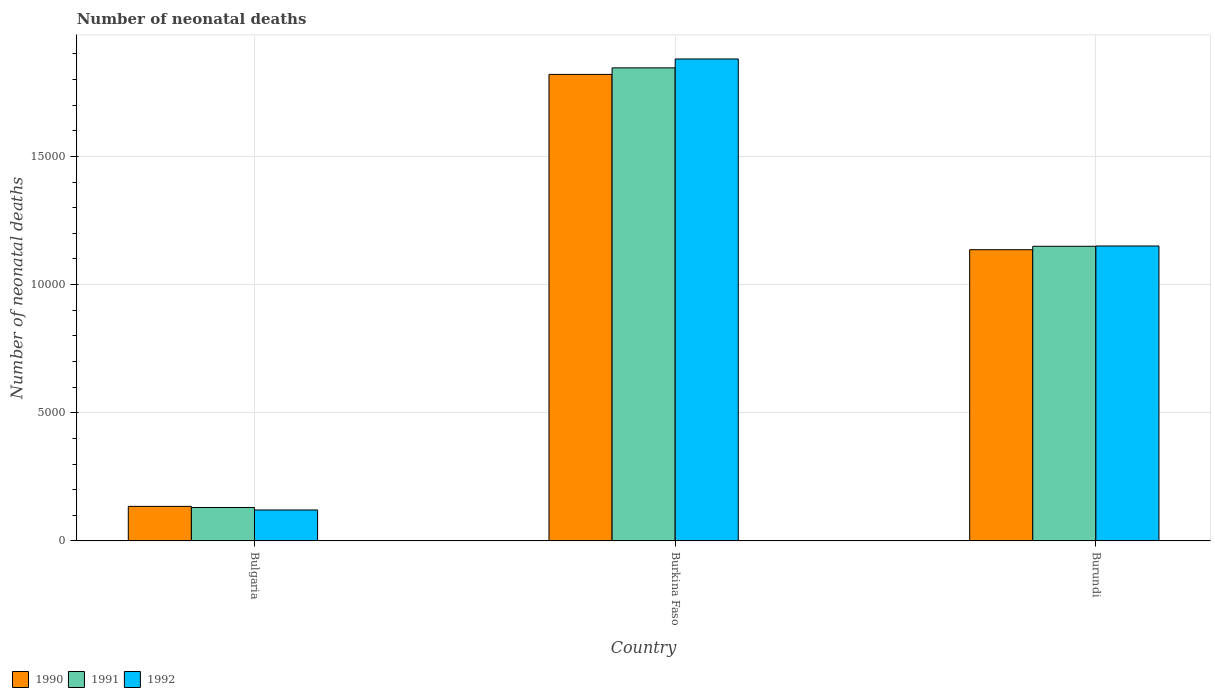How many different coloured bars are there?
Ensure brevity in your answer.  3. How many groups of bars are there?
Provide a succinct answer. 3. What is the number of neonatal deaths in in 1992 in Bulgaria?
Your answer should be very brief. 1208. Across all countries, what is the maximum number of neonatal deaths in in 1991?
Your response must be concise. 1.85e+04. Across all countries, what is the minimum number of neonatal deaths in in 1992?
Your answer should be compact. 1208. In which country was the number of neonatal deaths in in 1991 maximum?
Your response must be concise. Burkina Faso. What is the total number of neonatal deaths in in 1990 in the graph?
Make the answer very short. 3.09e+04. What is the difference between the number of neonatal deaths in in 1991 in Bulgaria and that in Burkina Faso?
Provide a short and direct response. -1.72e+04. What is the difference between the number of neonatal deaths in in 1991 in Burkina Faso and the number of neonatal deaths in in 1990 in Bulgaria?
Provide a short and direct response. 1.71e+04. What is the average number of neonatal deaths in in 1991 per country?
Your answer should be compact. 1.04e+04. What is the difference between the number of neonatal deaths in of/in 1991 and number of neonatal deaths in of/in 1992 in Burundi?
Keep it short and to the point. -11. What is the ratio of the number of neonatal deaths in in 1990 in Burkina Faso to that in Burundi?
Keep it short and to the point. 1.6. What is the difference between the highest and the second highest number of neonatal deaths in in 1990?
Your response must be concise. 6839. What is the difference between the highest and the lowest number of neonatal deaths in in 1990?
Offer a terse response. 1.69e+04. In how many countries, is the number of neonatal deaths in in 1990 greater than the average number of neonatal deaths in in 1990 taken over all countries?
Offer a terse response. 2. Is the sum of the number of neonatal deaths in in 1991 in Bulgaria and Burundi greater than the maximum number of neonatal deaths in in 1990 across all countries?
Offer a very short reply. No. What does the 1st bar from the right in Burkina Faso represents?
Make the answer very short. 1992. Are all the bars in the graph horizontal?
Keep it short and to the point. No. What is the difference between two consecutive major ticks on the Y-axis?
Your answer should be compact. 5000. Does the graph contain any zero values?
Provide a short and direct response. No. Does the graph contain grids?
Your answer should be compact. Yes. What is the title of the graph?
Keep it short and to the point. Number of neonatal deaths. What is the label or title of the X-axis?
Your response must be concise. Country. What is the label or title of the Y-axis?
Offer a very short reply. Number of neonatal deaths. What is the Number of neonatal deaths in 1990 in Bulgaria?
Provide a succinct answer. 1348. What is the Number of neonatal deaths in 1991 in Bulgaria?
Your response must be concise. 1305. What is the Number of neonatal deaths in 1992 in Bulgaria?
Your response must be concise. 1208. What is the Number of neonatal deaths in 1990 in Burkina Faso?
Offer a very short reply. 1.82e+04. What is the Number of neonatal deaths of 1991 in Burkina Faso?
Your response must be concise. 1.85e+04. What is the Number of neonatal deaths of 1992 in Burkina Faso?
Your answer should be very brief. 1.88e+04. What is the Number of neonatal deaths in 1990 in Burundi?
Ensure brevity in your answer.  1.14e+04. What is the Number of neonatal deaths in 1991 in Burundi?
Keep it short and to the point. 1.15e+04. What is the Number of neonatal deaths of 1992 in Burundi?
Your answer should be very brief. 1.15e+04. Across all countries, what is the maximum Number of neonatal deaths of 1990?
Your answer should be very brief. 1.82e+04. Across all countries, what is the maximum Number of neonatal deaths in 1991?
Offer a very short reply. 1.85e+04. Across all countries, what is the maximum Number of neonatal deaths in 1992?
Provide a succinct answer. 1.88e+04. Across all countries, what is the minimum Number of neonatal deaths of 1990?
Your response must be concise. 1348. Across all countries, what is the minimum Number of neonatal deaths in 1991?
Provide a short and direct response. 1305. Across all countries, what is the minimum Number of neonatal deaths of 1992?
Give a very brief answer. 1208. What is the total Number of neonatal deaths of 1990 in the graph?
Provide a succinct answer. 3.09e+04. What is the total Number of neonatal deaths in 1991 in the graph?
Offer a terse response. 3.13e+04. What is the total Number of neonatal deaths in 1992 in the graph?
Make the answer very short. 3.15e+04. What is the difference between the Number of neonatal deaths of 1990 in Bulgaria and that in Burkina Faso?
Your response must be concise. -1.69e+04. What is the difference between the Number of neonatal deaths of 1991 in Bulgaria and that in Burkina Faso?
Keep it short and to the point. -1.72e+04. What is the difference between the Number of neonatal deaths of 1992 in Bulgaria and that in Burkina Faso?
Ensure brevity in your answer.  -1.76e+04. What is the difference between the Number of neonatal deaths of 1990 in Bulgaria and that in Burundi?
Offer a very short reply. -1.00e+04. What is the difference between the Number of neonatal deaths of 1991 in Bulgaria and that in Burundi?
Make the answer very short. -1.02e+04. What is the difference between the Number of neonatal deaths in 1992 in Bulgaria and that in Burundi?
Provide a short and direct response. -1.03e+04. What is the difference between the Number of neonatal deaths of 1990 in Burkina Faso and that in Burundi?
Make the answer very short. 6839. What is the difference between the Number of neonatal deaths of 1991 in Burkina Faso and that in Burundi?
Give a very brief answer. 6960. What is the difference between the Number of neonatal deaths of 1992 in Burkina Faso and that in Burundi?
Offer a very short reply. 7296. What is the difference between the Number of neonatal deaths in 1990 in Bulgaria and the Number of neonatal deaths in 1991 in Burkina Faso?
Your answer should be very brief. -1.71e+04. What is the difference between the Number of neonatal deaths in 1990 in Bulgaria and the Number of neonatal deaths in 1992 in Burkina Faso?
Your answer should be compact. -1.75e+04. What is the difference between the Number of neonatal deaths of 1991 in Bulgaria and the Number of neonatal deaths of 1992 in Burkina Faso?
Keep it short and to the point. -1.75e+04. What is the difference between the Number of neonatal deaths in 1990 in Bulgaria and the Number of neonatal deaths in 1991 in Burundi?
Your answer should be very brief. -1.01e+04. What is the difference between the Number of neonatal deaths in 1990 in Bulgaria and the Number of neonatal deaths in 1992 in Burundi?
Offer a very short reply. -1.02e+04. What is the difference between the Number of neonatal deaths in 1991 in Bulgaria and the Number of neonatal deaths in 1992 in Burundi?
Your answer should be very brief. -1.02e+04. What is the difference between the Number of neonatal deaths in 1990 in Burkina Faso and the Number of neonatal deaths in 1991 in Burundi?
Offer a terse response. 6705. What is the difference between the Number of neonatal deaths of 1990 in Burkina Faso and the Number of neonatal deaths of 1992 in Burundi?
Ensure brevity in your answer.  6694. What is the difference between the Number of neonatal deaths of 1991 in Burkina Faso and the Number of neonatal deaths of 1992 in Burundi?
Ensure brevity in your answer.  6949. What is the average Number of neonatal deaths in 1990 per country?
Make the answer very short. 1.03e+04. What is the average Number of neonatal deaths of 1991 per country?
Your answer should be very brief. 1.04e+04. What is the average Number of neonatal deaths in 1992 per country?
Your answer should be very brief. 1.05e+04. What is the difference between the Number of neonatal deaths in 1990 and Number of neonatal deaths in 1992 in Bulgaria?
Make the answer very short. 140. What is the difference between the Number of neonatal deaths of 1991 and Number of neonatal deaths of 1992 in Bulgaria?
Offer a very short reply. 97. What is the difference between the Number of neonatal deaths of 1990 and Number of neonatal deaths of 1991 in Burkina Faso?
Keep it short and to the point. -255. What is the difference between the Number of neonatal deaths in 1990 and Number of neonatal deaths in 1992 in Burkina Faso?
Keep it short and to the point. -602. What is the difference between the Number of neonatal deaths of 1991 and Number of neonatal deaths of 1992 in Burkina Faso?
Make the answer very short. -347. What is the difference between the Number of neonatal deaths of 1990 and Number of neonatal deaths of 1991 in Burundi?
Your answer should be very brief. -134. What is the difference between the Number of neonatal deaths in 1990 and Number of neonatal deaths in 1992 in Burundi?
Offer a very short reply. -145. What is the difference between the Number of neonatal deaths in 1991 and Number of neonatal deaths in 1992 in Burundi?
Provide a short and direct response. -11. What is the ratio of the Number of neonatal deaths in 1990 in Bulgaria to that in Burkina Faso?
Offer a terse response. 0.07. What is the ratio of the Number of neonatal deaths in 1991 in Bulgaria to that in Burkina Faso?
Provide a short and direct response. 0.07. What is the ratio of the Number of neonatal deaths in 1992 in Bulgaria to that in Burkina Faso?
Your answer should be compact. 0.06. What is the ratio of the Number of neonatal deaths in 1990 in Bulgaria to that in Burundi?
Provide a succinct answer. 0.12. What is the ratio of the Number of neonatal deaths of 1991 in Bulgaria to that in Burundi?
Give a very brief answer. 0.11. What is the ratio of the Number of neonatal deaths in 1992 in Bulgaria to that in Burundi?
Ensure brevity in your answer.  0.1. What is the ratio of the Number of neonatal deaths of 1990 in Burkina Faso to that in Burundi?
Keep it short and to the point. 1.6. What is the ratio of the Number of neonatal deaths in 1991 in Burkina Faso to that in Burundi?
Give a very brief answer. 1.61. What is the ratio of the Number of neonatal deaths of 1992 in Burkina Faso to that in Burundi?
Ensure brevity in your answer.  1.63. What is the difference between the highest and the second highest Number of neonatal deaths of 1990?
Give a very brief answer. 6839. What is the difference between the highest and the second highest Number of neonatal deaths in 1991?
Provide a short and direct response. 6960. What is the difference between the highest and the second highest Number of neonatal deaths in 1992?
Provide a short and direct response. 7296. What is the difference between the highest and the lowest Number of neonatal deaths in 1990?
Make the answer very short. 1.69e+04. What is the difference between the highest and the lowest Number of neonatal deaths of 1991?
Give a very brief answer. 1.72e+04. What is the difference between the highest and the lowest Number of neonatal deaths in 1992?
Your answer should be very brief. 1.76e+04. 